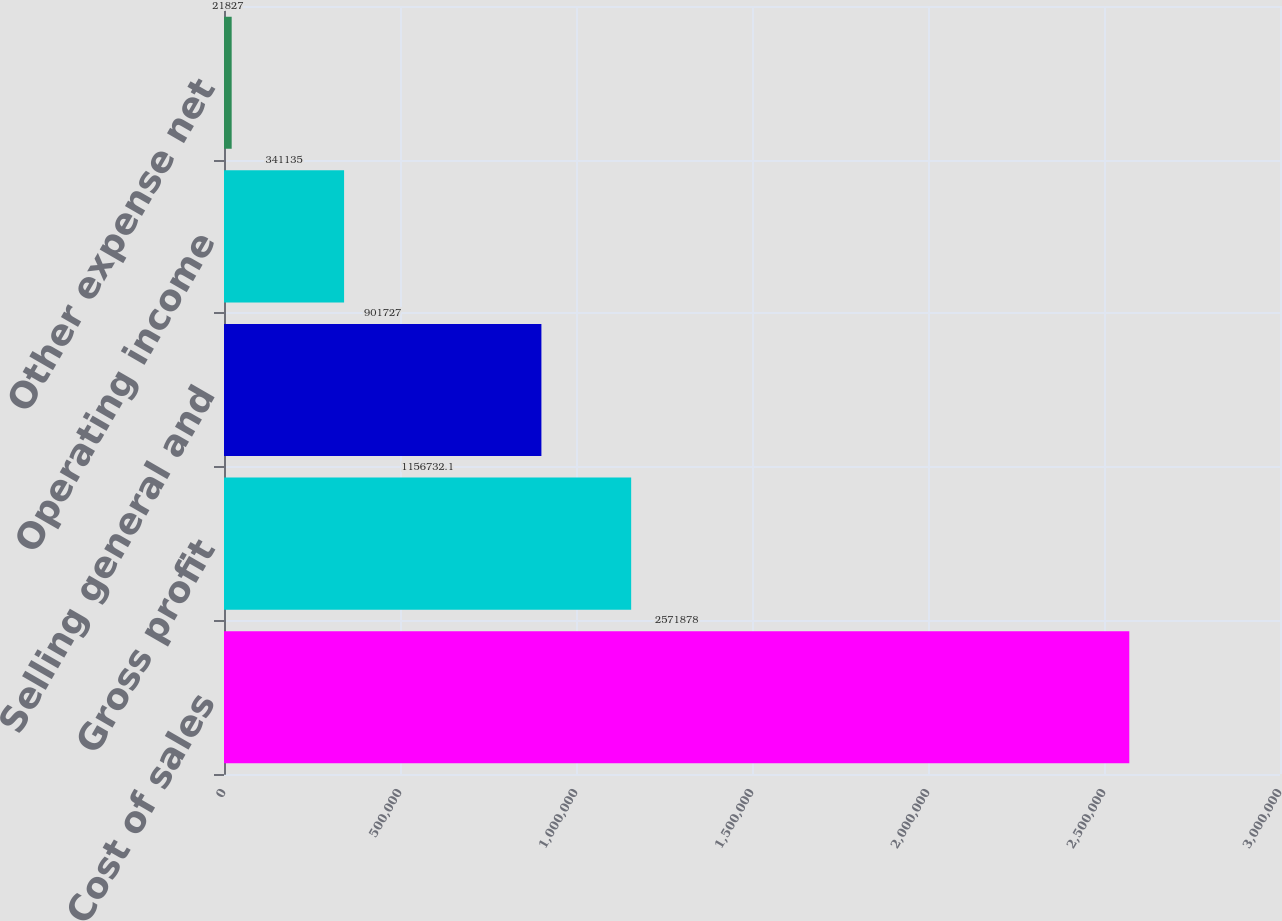Convert chart. <chart><loc_0><loc_0><loc_500><loc_500><bar_chart><fcel>Cost of sales<fcel>Gross profit<fcel>Selling general and<fcel>Operating income<fcel>Other expense net<nl><fcel>2.57188e+06<fcel>1.15673e+06<fcel>901727<fcel>341135<fcel>21827<nl></chart> 